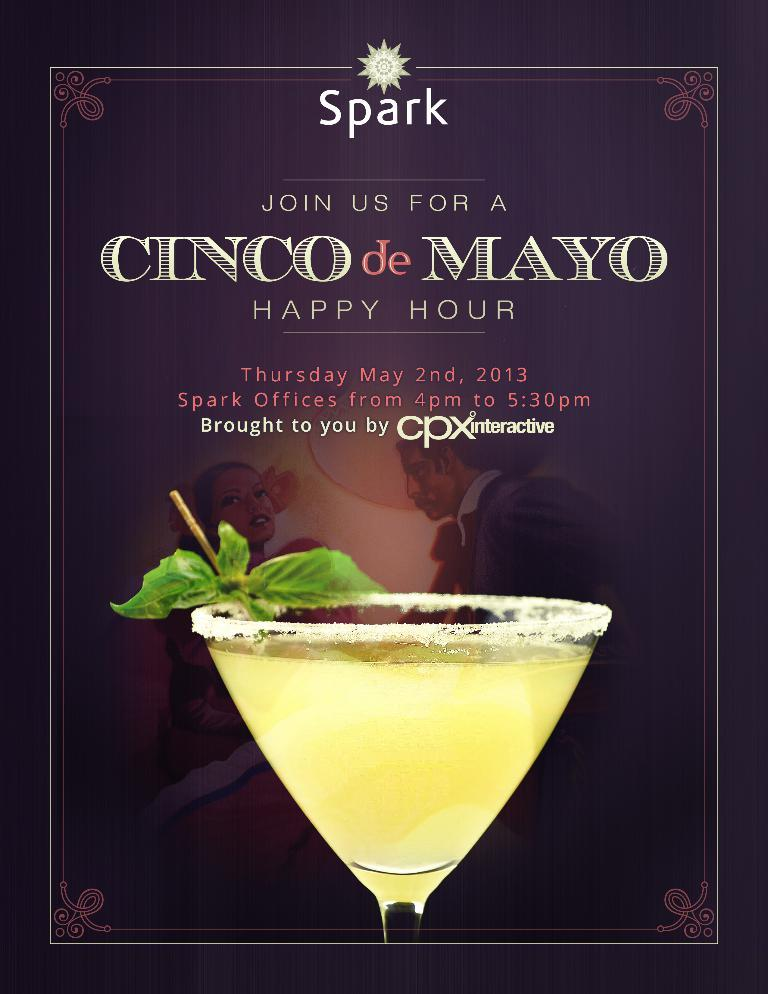What type of document is shown in the image? The image is a menu card of a restaurant. Can you describe any specific items or images on the menu card? Yes, there is an image of a cocktail glass on the menu card. What type of airport is featured in the image? There is no airport present in the image; it is a menu card of a restaurant. Can you recite a verse from the son in the image? There is no son or verse present in the image; it is a menu card of a restaurant with an image of a cocktail glass. 